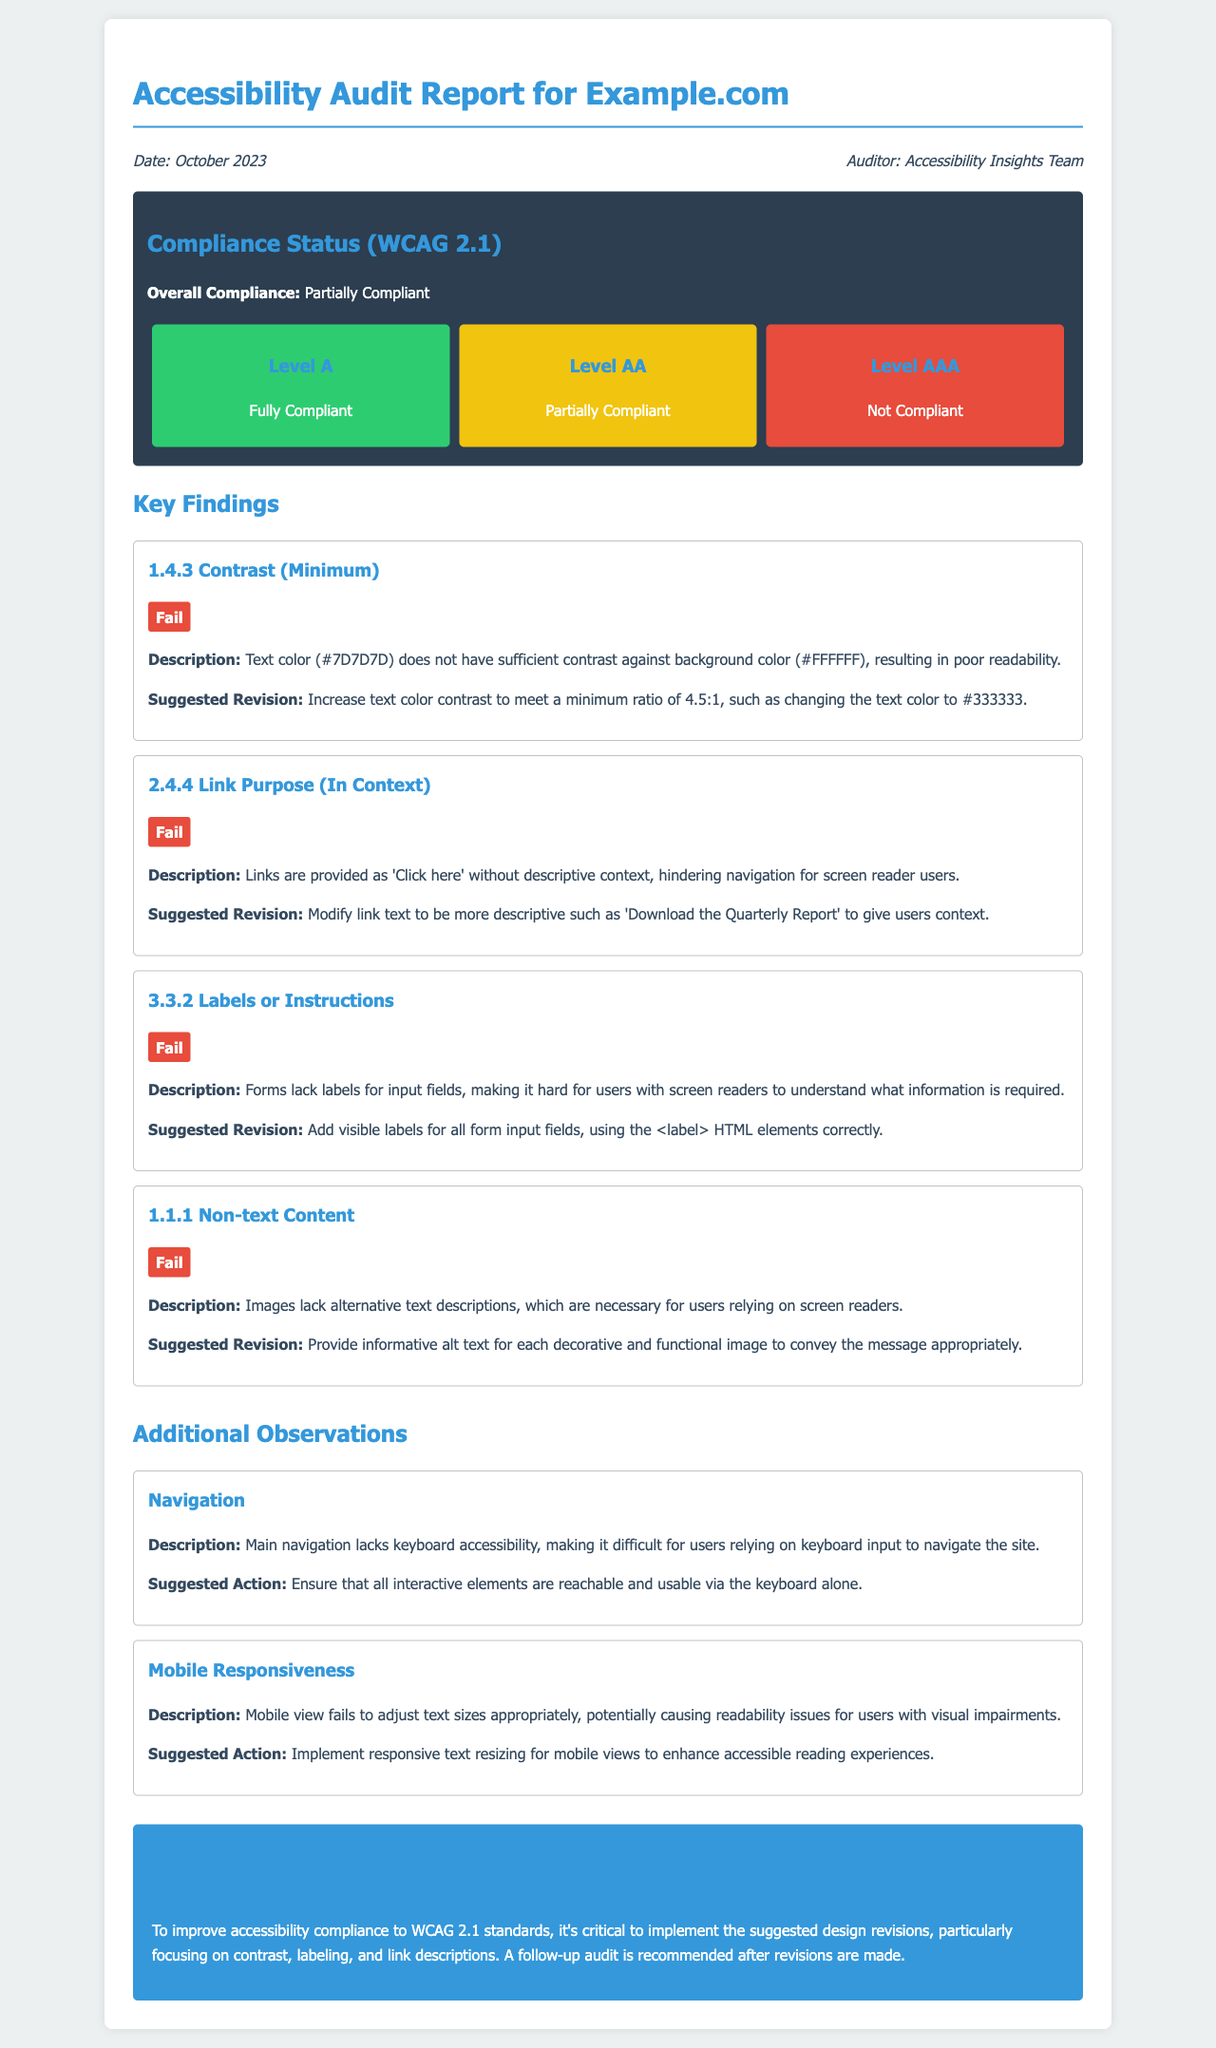What is the date of the audit? The date of the audit is stated in the meta-info section of the document.
Answer: October 2023 Who conducted the audit? The auditor's name is mentioned in the meta-info section.
Answer: Accessibility Insights Team What is the overall compliance status? The overall compliance status is clearly indicated in the compliance status section.
Answer: Partially Compliant How many findings failed? The number of findings can be counted from the key findings section of the report.
Answer: Four What is the suggested revision for contrast minimum? The suggested revision for the contrast issue is mentioned in the first finding.
Answer: Increase text color contrast to meet a minimum ratio of 4.5:1 What is one observation made regarding navigation? The observation about navigation addresses a specific issue identified in the document.
Answer: Main navigation lacks keyboard accessibility What action is suggested for mobile responsiveness? The suggested action for mobile responsiveness is specified in the observations section of the report.
Answer: Implement responsive text resizing What compliance level is fully compliant? The compliance levels outline the status for various levels of compliance mentioned in the document.
Answer: Level A What is the main focus for improvement according to the conclusion? The conclusion summarizes the critical areas that need improvement for better accessibility.
Answer: Contrast, labeling, and link descriptions 